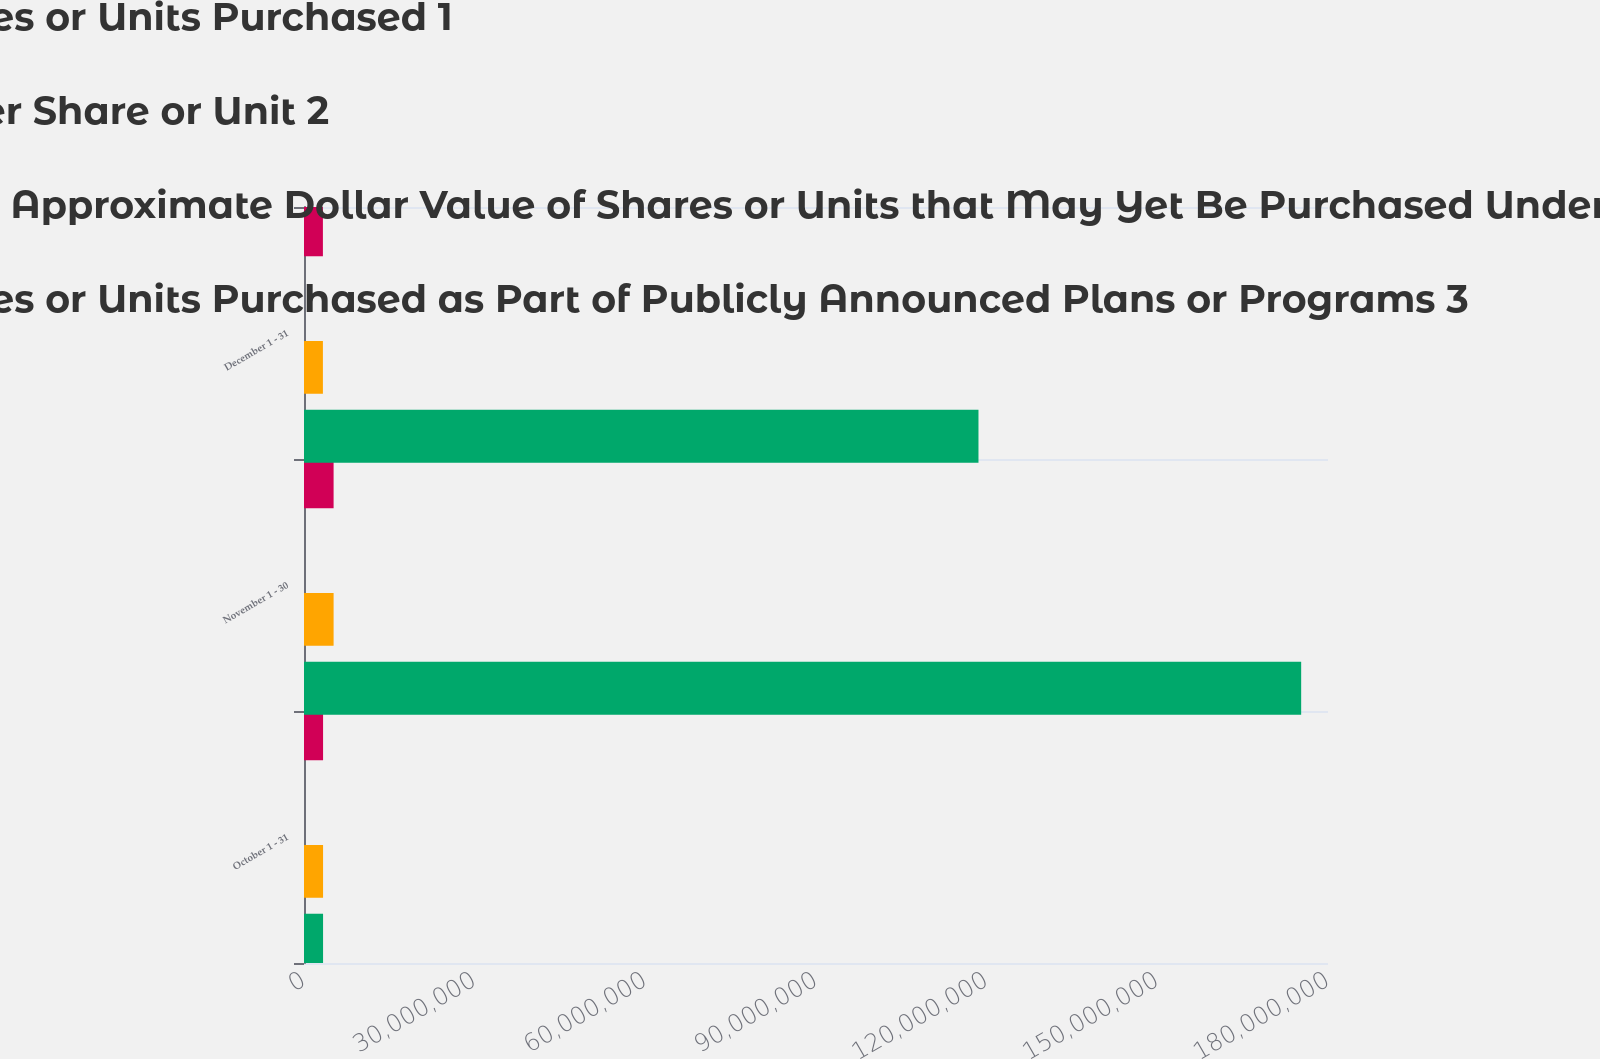<chart> <loc_0><loc_0><loc_500><loc_500><stacked_bar_chart><ecel><fcel>October 1 - 31<fcel>November 1 - 30<fcel>December 1 - 31<nl><fcel>Total Number of Shares or Units Purchased 1<fcel>3.35176e+06<fcel>5.20222e+06<fcel>3.32373e+06<nl><fcel>Average Price Paid per Share or Unit 2<fcel>16.63<fcel>17<fcel>17.07<nl><fcel>Maximum Number or Approximate Dollar Value of Shares or Units that May Yet Be Purchased Under the Plans or Programs 3<fcel>3.35069e+06<fcel>5.20222e+06<fcel>3.32373e+06<nl><fcel>Total Number of Shares or Units Purchased as Part of Publicly Announced Plans or Programs 3<fcel>3.35069e+06<fcel>1.75284e+08<fcel>1.18561e+08<nl></chart> 